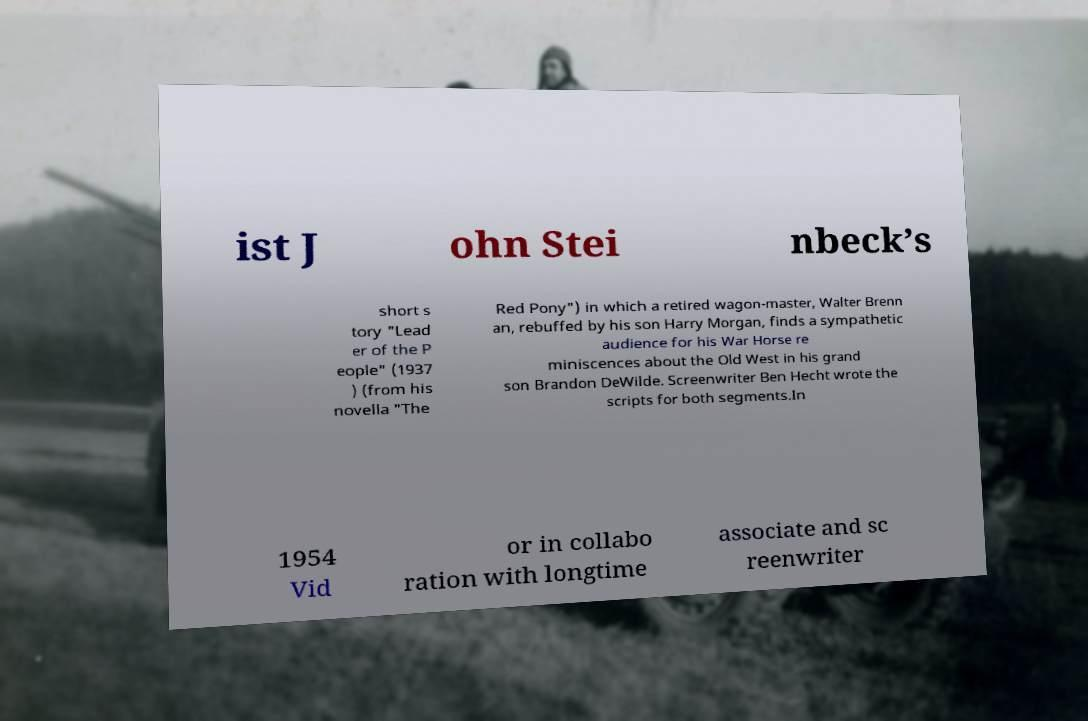Please read and relay the text visible in this image. What does it say? ist J ohn Stei nbeck’s short s tory "Lead er of the P eople" (1937 ) (from his novella "The Red Pony") in which a retired wagon-master, Walter Brenn an, rebuffed by his son Harry Morgan, finds a sympathetic audience for his War Horse re miniscences about the Old West in his grand son Brandon DeWilde. Screenwriter Ben Hecht wrote the scripts for both segments.In 1954 Vid or in collabo ration with longtime associate and sc reenwriter 